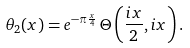Convert formula to latex. <formula><loc_0><loc_0><loc_500><loc_500>\theta _ { 2 } ( x ) = e ^ { - \pi \frac { x } { 4 } } \, \Theta \left ( \frac { i x } { 2 } , i x \right ) .</formula> 